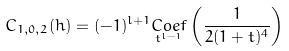Convert formula to latex. <formula><loc_0><loc_0><loc_500><loc_500>C _ { 1 , 0 , 2 } ( h ) = ( - 1 ) ^ { l + 1 } \underset { t ^ { l - 1 } } { C o e f } \left ( \frac { 1 } { 2 ( 1 + t ) ^ { 4 } } \right )</formula> 